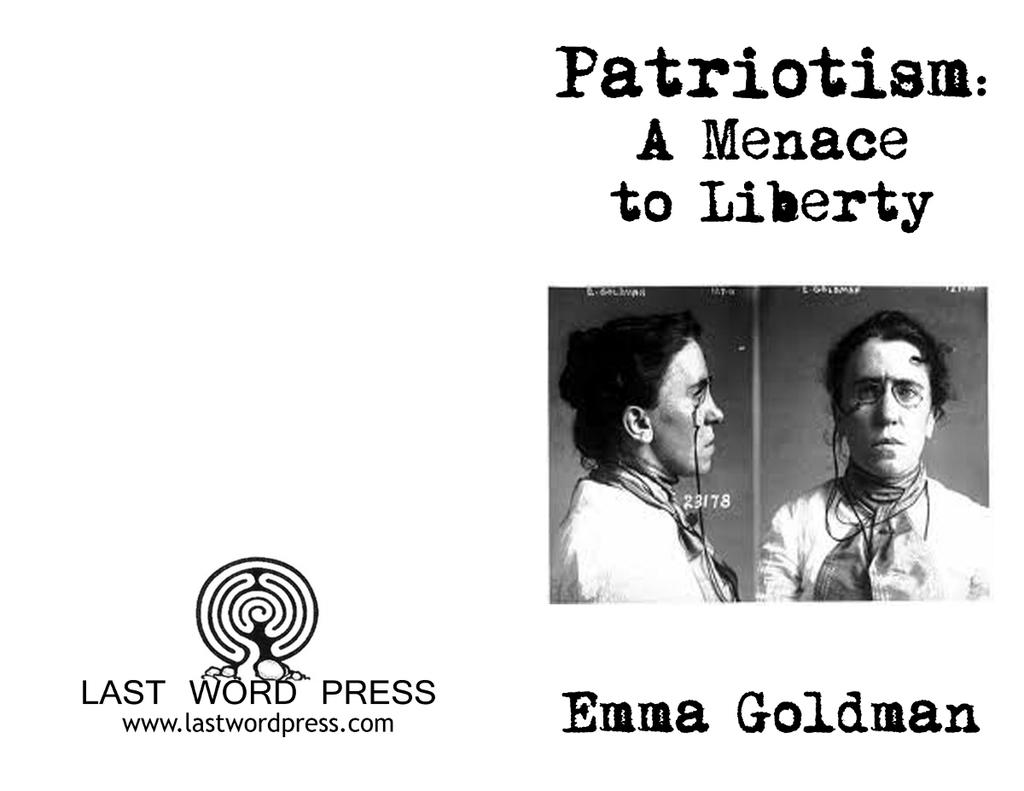What is present on the left side of the image? There is a poster, text, and a logo on the left side of the image. What can be seen on the right side of the image? There are two pictures and text on the right side of the image. What type of noise can be heard coming from the dolls in the image? There are no dolls present in the image, so it is not possible to determine what noise might be heard. 